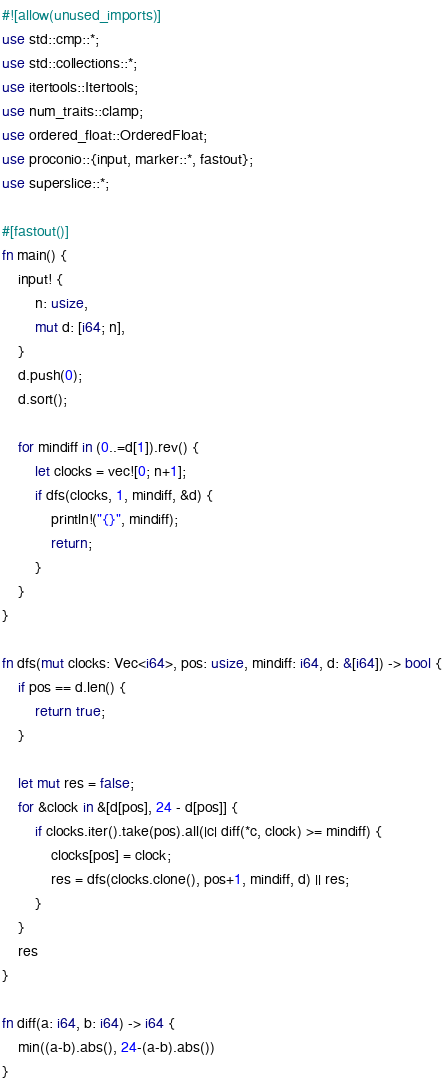Convert code to text. <code><loc_0><loc_0><loc_500><loc_500><_Rust_>#![allow(unused_imports)]
use std::cmp::*;
use std::collections::*;
use itertools::Itertools;
use num_traits::clamp;
use ordered_float::OrderedFloat;
use proconio::{input, marker::*, fastout};
use superslice::*;

#[fastout()]
fn main() {
    input! {
        n: usize,
        mut d: [i64; n],
    }
    d.push(0);
    d.sort();

    for mindiff in (0..=d[1]).rev() {
        let clocks = vec![0; n+1];
        if dfs(clocks, 1, mindiff, &d) {
            println!("{}", mindiff);
            return;
        }
    }
}

fn dfs(mut clocks: Vec<i64>, pos: usize, mindiff: i64, d: &[i64]) -> bool {
    if pos == d.len() {
        return true;
    }

    let mut res = false;
    for &clock in &[d[pos], 24 - d[pos]] {
        if clocks.iter().take(pos).all(|c| diff(*c, clock) >= mindiff) {
            clocks[pos] = clock;
            res = dfs(clocks.clone(), pos+1, mindiff, d) || res;
        }
    }
    res
}

fn diff(a: i64, b: i64) -> i64 {
    min((a-b).abs(), 24-(a-b).abs())
}</code> 